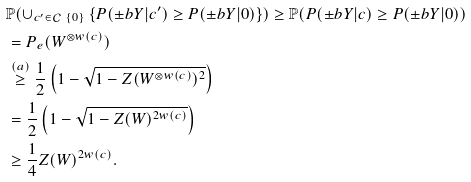Convert formula to latex. <formula><loc_0><loc_0><loc_500><loc_500>& \mathbb { P } ( \cup _ { c ^ { \prime } \in \mathcal { C } \ \{ 0 \} } \left \{ P ( \pm b { Y } | c ^ { \prime } ) \geq P ( \pm b { Y } | 0 ) \right \} ) \geq \mathbb { P } ( P ( \pm b { Y } | c ) \geq P ( \pm b { Y } | 0 ) ) \\ & = P _ { e } ( W ^ { \otimes w ( c ) } ) \\ & \stackrel { ( a ) } { \geq } \frac { 1 } { 2 } \left ( 1 - \sqrt { 1 - Z ( W ^ { \otimes w ( c ) } ) ^ { 2 } } \right ) \\ & = \frac { 1 } { 2 } \left ( 1 - \sqrt { 1 - Z ( W ) ^ { 2 w ( c ) } } \right ) \\ & \geq \frac { 1 } { 4 } Z ( W ) ^ { 2 w ( c ) } .</formula> 